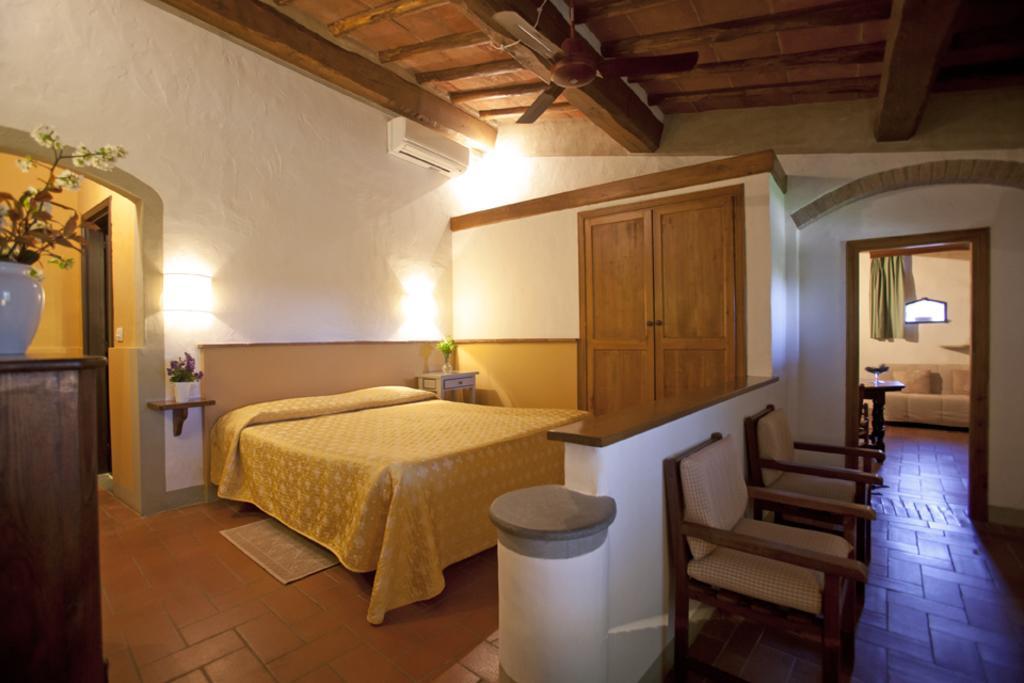How would you summarize this image in a sentence or two? In this picture I can see the inside view of a room and in the front of this picture I can see 2 chairs and I see a white and brown color thing. In the middle of this picture I can see a bed, 2 plants and in the background I can see the wall, on which there are lights and I can see an AC. I can also see the doors and on the top of this picture I can see a fan. On the left side of this image I can see the brown color thing, on which there is a flower vase. On the right side of this picture I can see another room. 